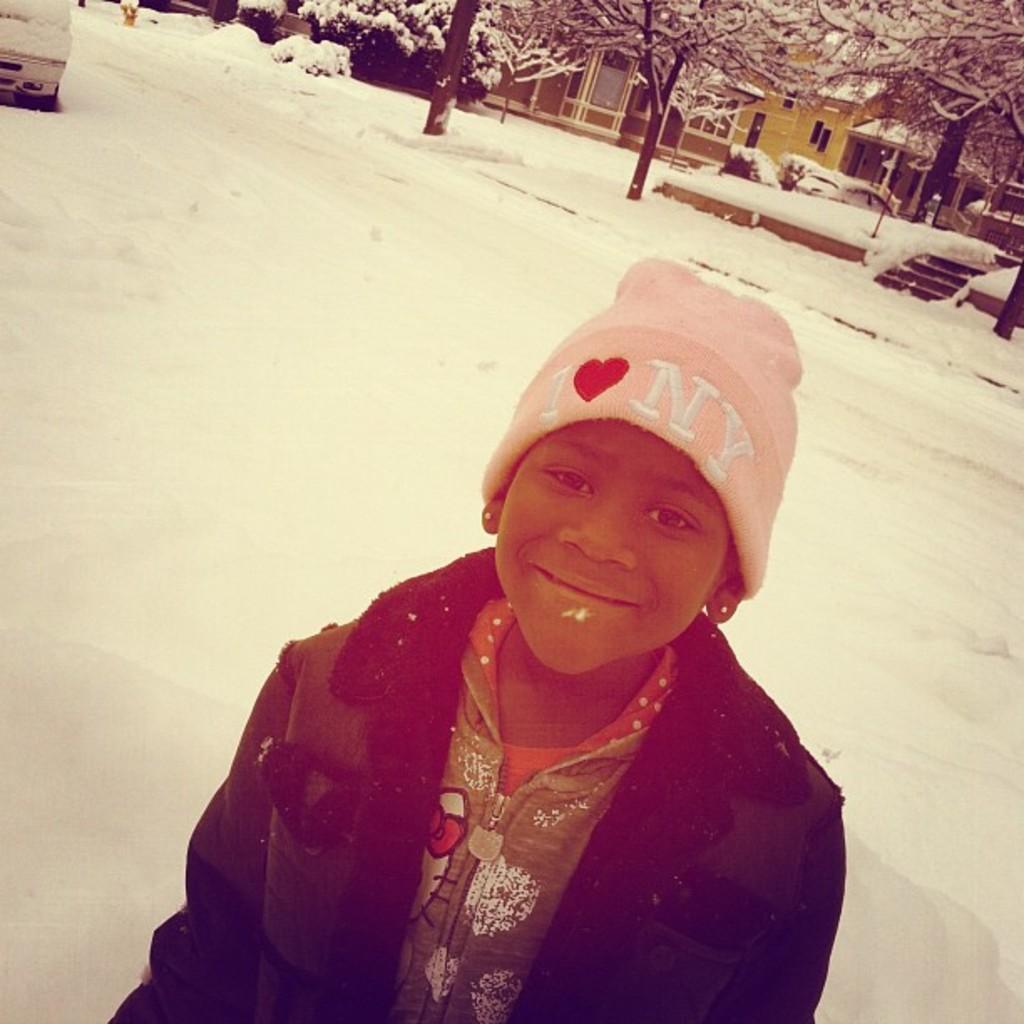Could you give a brief overview of what you see in this image? In this image I can see a person wearing pink cap, green dress and jacket is standing on the snow. In the background I can see a car, few buildings, few trees and the snow. 